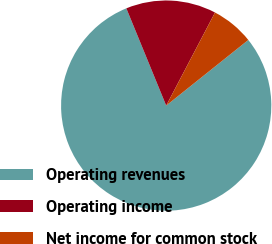Convert chart to OTSL. <chart><loc_0><loc_0><loc_500><loc_500><pie_chart><fcel>Operating revenues<fcel>Operating income<fcel>Net income for common stock<nl><fcel>79.55%<fcel>13.88%<fcel>6.58%<nl></chart> 